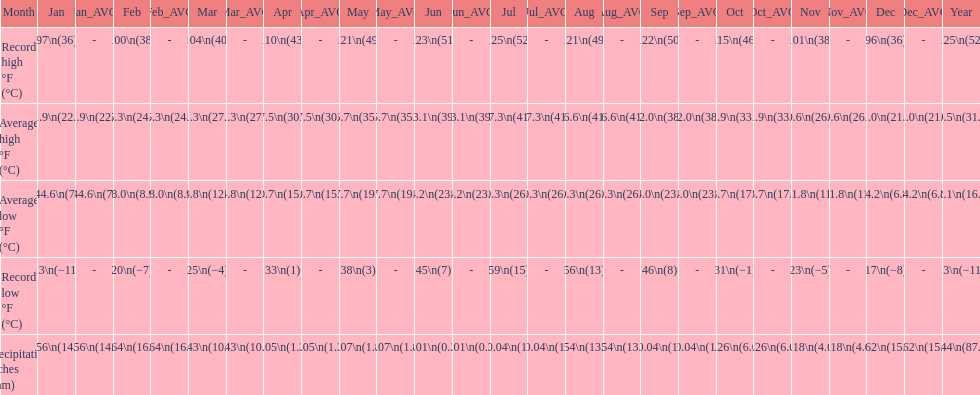How long was the monthly average temperature 100 degrees or more? 4 months. Could you parse the entire table? {'header': ['Month', 'Jan', 'Jan_AVG', 'Feb', 'Feb_AVG', 'Mar', 'Mar_AVG', 'Apr', 'Apr_AVG', 'May', 'May_AVG', 'Jun', 'Jun_AVG', 'Jul', 'Jul_AVG', 'Aug', 'Aug_AVG', 'Sep', 'Sep_AVG', 'Oct', 'Oct_AVG', 'Nov', 'Nov_AVG', 'Dec', 'Dec_AVG', 'Year'], 'rows': [['Record high °F (°C)', '97\\n(36)', '-', '100\\n(38)', '-', '104\\n(40)', '-', '110\\n(43)', '-', '121\\n(49)', '-', '123\\n(51)', '-', '125\\n(52)', '-', '121\\n(49)', '-', '122\\n(50)', '-', '115\\n(46)', '-', '101\\n(38)', '-', '96\\n(36)', '-', '125\\n(52)'], ['Average high °F (°C)', '71.9\\n(22.2)', '71.9\\n(22.2)', '75.3\\n(24.1)', '75.3\\n(24.1)', '81.3\\n(27.4)', '81.3\\n(27.4)', '87.5\\n(30.8)', '87.5\\n(30.8)', '95.7\\n(35.4)', '95.7\\n(35.4)', '103.1\\n(39.5)', '103.1\\n(39.5)', '107.3\\n(41.8)', '107.3\\n(41.8)', '106.6\\n(41.4)', '106.6\\n(41.4)', '102.0\\n(38.9)', '102.0\\n(38.9)', '91.9\\n(33.3)', '91.9\\n(33.3)', '79.6\\n(26.4)', '79.6\\n(26.4)', '71.0\\n(21.7)', '71.0\\n(21.7)', '89.5\\n(31.9)'], ['Average low °F (°C)', '44.6\\n(7)', '44.6\\n(7)', '48.0\\n(8.9)', '48.0\\n(8.9)', '54.8\\n(12.7)', '54.8\\n(12.7)', '60.7\\n(15.9)', '60.7\\n(15.9)', '67.7\\n(19.8)', '67.7\\n(19.8)', '74.2\\n(23.4)', '74.2\\n(23.4)', '80.3\\n(26.8)', '80.3\\n(26.8)', '80.3\\n(26.8)', '80.3\\n(26.8)', '74.0\\n(23.3)', '74.0\\n(23.3)', '63.7\\n(17.6)', '63.7\\n(17.6)', '51.8\\n(11)', '51.8\\n(11)', '44.2\\n(6.8)', '44.2\\n(6.8)', '62.1\\n(16.7)'], ['Record low °F (°C)', '13\\n(−11)', '-', '20\\n(−7)', '-', '25\\n(−4)', '-', '33\\n(1)', '-', '38\\n(3)', '-', '45\\n(7)', '-', '59\\n(15)', '-', '56\\n(13)', '-', '46\\n(8)', '-', '31\\n(−1)', '-', '23\\n(−5)', '-', '17\\n(−8)', '-', '13\\n(−11)'], ['Precipitation inches (mm)', '0.56\\n(14.2)', '0.56\\n(14.2)', '0.64\\n(16.3)', '0.64\\n(16.3)', '0.43\\n(10.9)', '0.43\\n(10.9)', '0.05\\n(1.3)', '0.05\\n(1.3)', '0.07\\n(1.8)', '0.07\\n(1.8)', '0.01\\n(0.3)', '0.01\\n(0.3)', '0.04\\n(1)', '0.04\\n(1)', '0.54\\n(13.7)', '0.54\\n(13.7)', '0.04\\n(1)', '0.04\\n(1)', '0.26\\n(6.6)', '0.26\\n(6.6)', '0.18\\n(4.6)', '0.18\\n(4.6)', '0.62\\n(15.7)', '0.62\\n(15.7)', '3.44\\n(87.4)']]} 